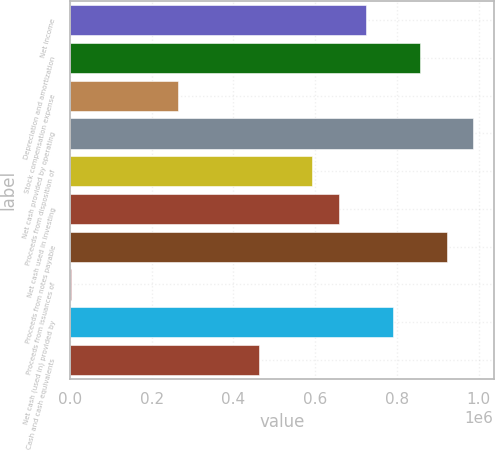Convert chart. <chart><loc_0><loc_0><loc_500><loc_500><bar_chart><fcel>Net income<fcel>Depreciation and amortization<fcel>Stock compensation expense<fcel>Net cash provided by operating<fcel>Proceeds from disposition of<fcel>Net cash used in investing<fcel>Proceeds from notes payable<fcel>Proceeds from issuances of<fcel>Net cash (used in) provided by<fcel>Cash and cash equivalents<nl><fcel>724209<fcel>855600<fcel>264339<fcel>986991<fcel>592817<fcel>658513<fcel>921295<fcel>1557<fcel>789904<fcel>461426<nl></chart> 